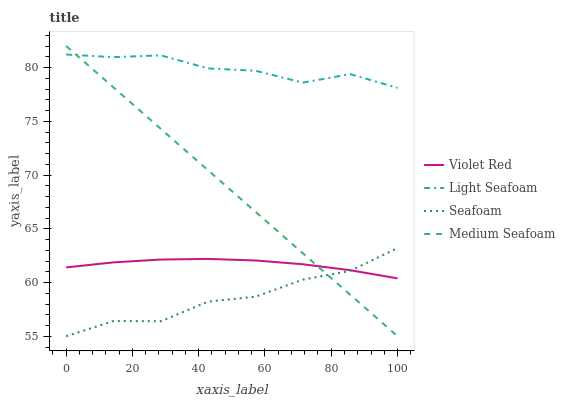Does Seafoam have the minimum area under the curve?
Answer yes or no. Yes. Does Light Seafoam have the maximum area under the curve?
Answer yes or no. Yes. Does Light Seafoam have the minimum area under the curve?
Answer yes or no. No. Does Seafoam have the maximum area under the curve?
Answer yes or no. No. Is Medium Seafoam the smoothest?
Answer yes or no. Yes. Is Seafoam the roughest?
Answer yes or no. Yes. Is Light Seafoam the smoothest?
Answer yes or no. No. Is Light Seafoam the roughest?
Answer yes or no. No. Does Light Seafoam have the lowest value?
Answer yes or no. No. Does Light Seafoam have the highest value?
Answer yes or no. No. Is Violet Red less than Light Seafoam?
Answer yes or no. Yes. Is Light Seafoam greater than Violet Red?
Answer yes or no. Yes. Does Violet Red intersect Light Seafoam?
Answer yes or no. No. 